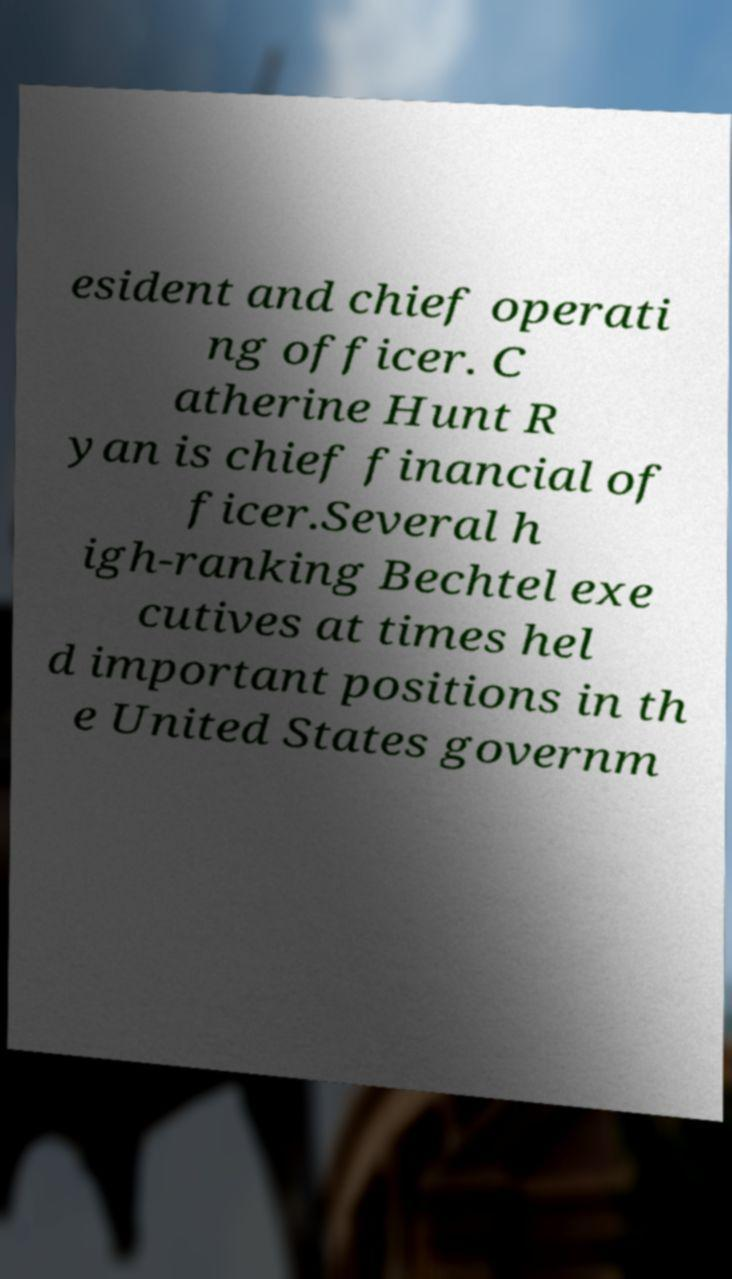Could you extract and type out the text from this image? esident and chief operati ng officer. C atherine Hunt R yan is chief financial of ficer.Several h igh-ranking Bechtel exe cutives at times hel d important positions in th e United States governm 